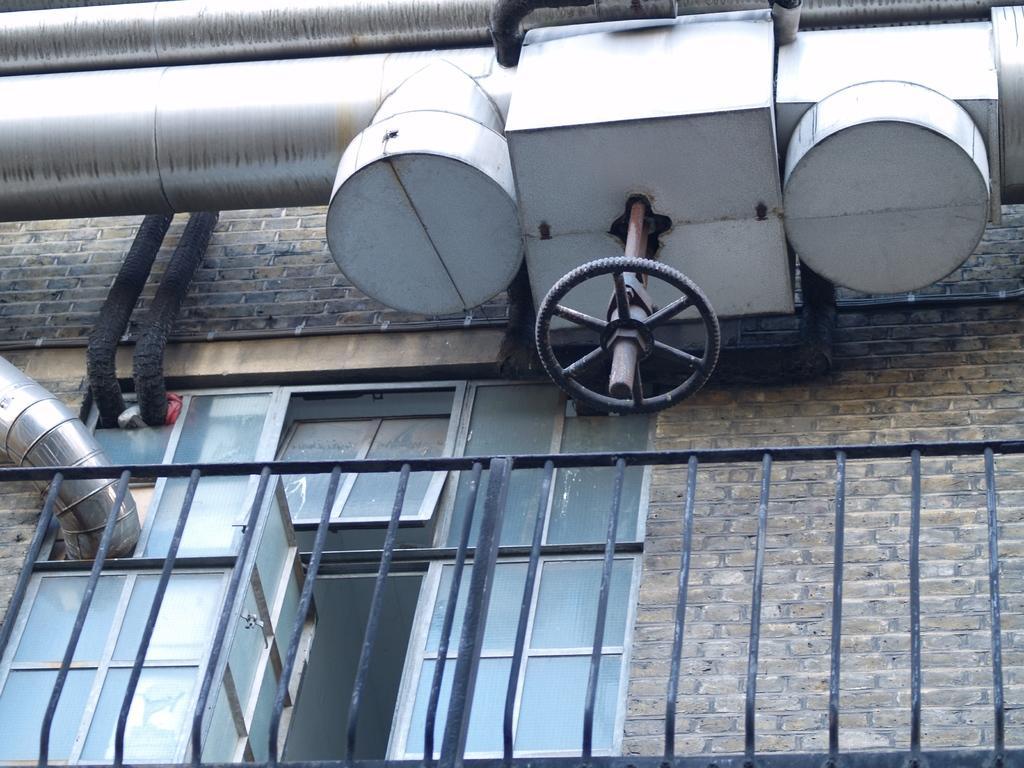Describe this image in one or two sentences. In this picture there is a window on the left side of the image and there is a boundary in front of it and there are pipes at the top side of the image. 